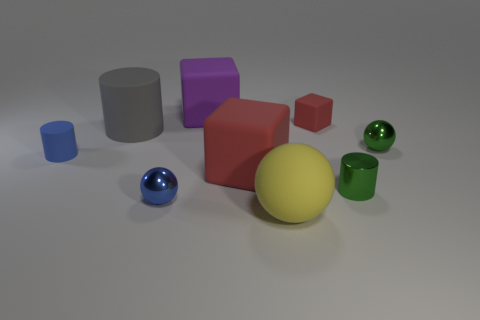Subtract all tiny red rubber cubes. How many cubes are left? 2 Subtract all blue spheres. How many spheres are left? 2 Add 1 tiny yellow rubber spheres. How many objects exist? 10 Subtract 0 cyan spheres. How many objects are left? 9 Subtract all cylinders. How many objects are left? 6 Subtract 3 cylinders. How many cylinders are left? 0 Subtract all gray balls. Subtract all purple cylinders. How many balls are left? 3 Subtract all blue cylinders. How many brown spheres are left? 0 Subtract all small rubber things. Subtract all matte balls. How many objects are left? 6 Add 1 yellow matte things. How many yellow matte things are left? 2 